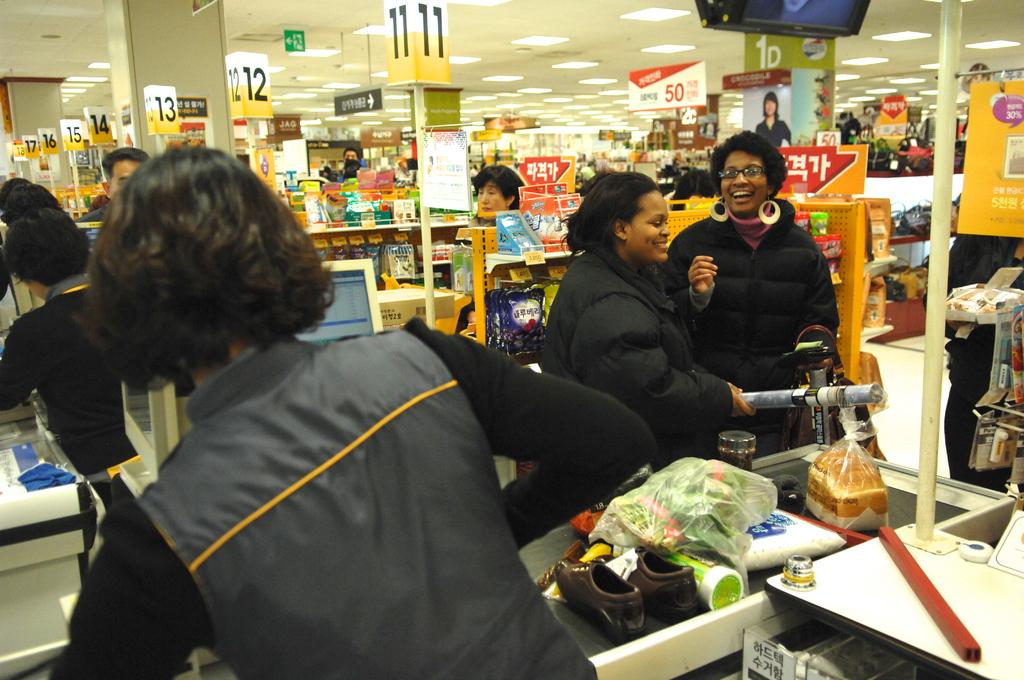What register are the two ladies checking out at?
Offer a very short reply. 11. What number is on the sign handing from the ceiling and printed in red?
Offer a very short reply. 50. 